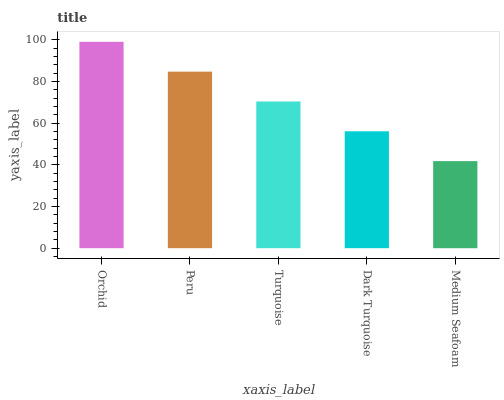Is Medium Seafoam the minimum?
Answer yes or no. Yes. Is Orchid the maximum?
Answer yes or no. Yes. Is Peru the minimum?
Answer yes or no. No. Is Peru the maximum?
Answer yes or no. No. Is Orchid greater than Peru?
Answer yes or no. Yes. Is Peru less than Orchid?
Answer yes or no. Yes. Is Peru greater than Orchid?
Answer yes or no. No. Is Orchid less than Peru?
Answer yes or no. No. Is Turquoise the high median?
Answer yes or no. Yes. Is Turquoise the low median?
Answer yes or no. Yes. Is Medium Seafoam the high median?
Answer yes or no. No. Is Peru the low median?
Answer yes or no. No. 